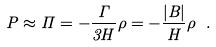Convert formula to latex. <formula><loc_0><loc_0><loc_500><loc_500>P \approx \Pi = - \frac { \Gamma } { 3 H } \rho = - \frac { | B | } { H } \rho \ .</formula> 